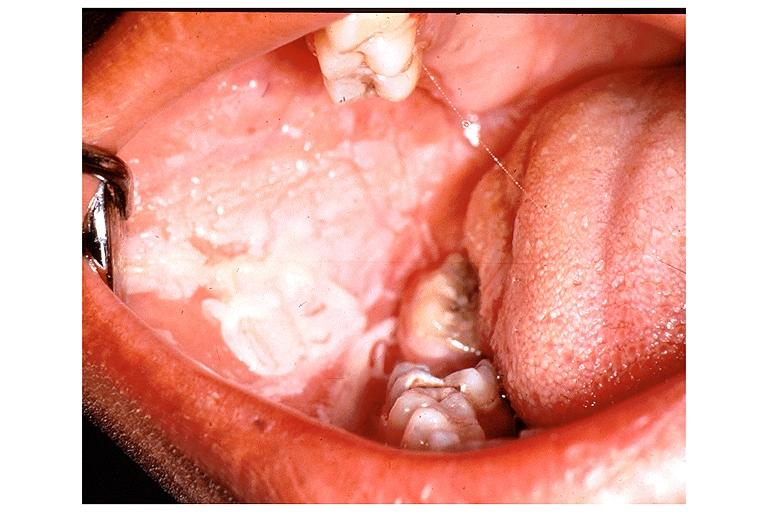what burn from topical asprin?
Answer the question using a single word or phrase. Chemical 